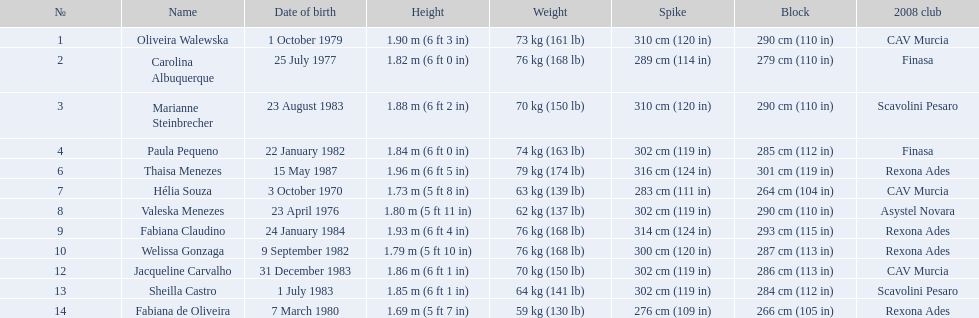Can you provide the heights of the players? 1.90 m (6 ft 3 in), 1.82 m (6 ft 0 in), 1.88 m (6 ft 2 in), 1.84 m (6 ft 0 in), 1.96 m (6 ft 5 in), 1.73 m (5 ft 8 in), 1.80 m (5 ft 11 in), 1.93 m (6 ft 4 in), 1.79 m (5 ft 10 in), 1.86 m (6 ft 1 in), 1.85 m (6 ft 1 in), 1.69 m (5 ft 7 in). Who has the shortest height? 1.69 m (5 ft 7 in). Which player has a height of 5'7? Fabiana de Oliveira. 